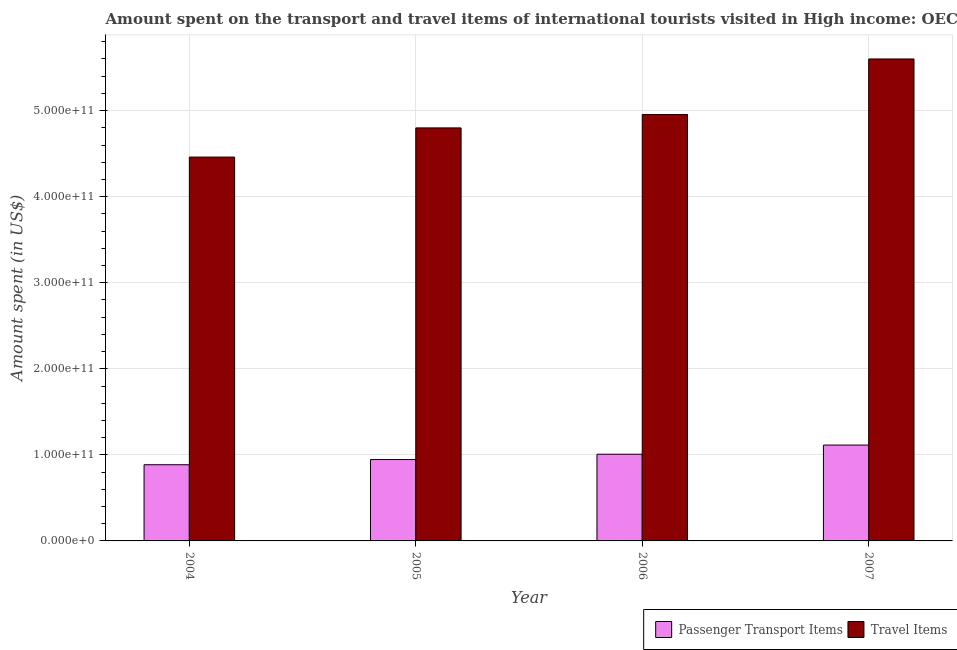How many different coloured bars are there?
Your response must be concise. 2. Are the number of bars per tick equal to the number of legend labels?
Give a very brief answer. Yes. What is the label of the 4th group of bars from the left?
Give a very brief answer. 2007. In how many cases, is the number of bars for a given year not equal to the number of legend labels?
Your answer should be compact. 0. What is the amount spent in travel items in 2005?
Your answer should be compact. 4.80e+11. Across all years, what is the maximum amount spent on passenger transport items?
Keep it short and to the point. 1.11e+11. Across all years, what is the minimum amount spent on passenger transport items?
Provide a succinct answer. 8.85e+1. In which year was the amount spent on passenger transport items maximum?
Give a very brief answer. 2007. In which year was the amount spent in travel items minimum?
Ensure brevity in your answer.  2004. What is the total amount spent in travel items in the graph?
Your answer should be compact. 1.98e+12. What is the difference between the amount spent on passenger transport items in 2004 and that in 2006?
Provide a succinct answer. -1.22e+1. What is the difference between the amount spent on passenger transport items in 2005 and the amount spent in travel items in 2004?
Offer a terse response. 6.03e+09. What is the average amount spent in travel items per year?
Your answer should be very brief. 4.95e+11. In the year 2006, what is the difference between the amount spent on passenger transport items and amount spent in travel items?
Offer a terse response. 0. In how many years, is the amount spent in travel items greater than 400000000000 US$?
Provide a short and direct response. 4. What is the ratio of the amount spent on passenger transport items in 2005 to that in 2007?
Offer a very short reply. 0.85. Is the amount spent in travel items in 2004 less than that in 2007?
Ensure brevity in your answer.  Yes. Is the difference between the amount spent on passenger transport items in 2004 and 2007 greater than the difference between the amount spent in travel items in 2004 and 2007?
Give a very brief answer. No. What is the difference between the highest and the second highest amount spent on passenger transport items?
Your answer should be very brief. 1.06e+1. What is the difference between the highest and the lowest amount spent on passenger transport items?
Make the answer very short. 2.28e+1. In how many years, is the amount spent on passenger transport items greater than the average amount spent on passenger transport items taken over all years?
Provide a succinct answer. 2. What does the 2nd bar from the left in 2004 represents?
Give a very brief answer. Travel Items. What does the 1st bar from the right in 2006 represents?
Your answer should be very brief. Travel Items. How many bars are there?
Provide a short and direct response. 8. What is the difference between two consecutive major ticks on the Y-axis?
Your answer should be very brief. 1.00e+11. Does the graph contain any zero values?
Give a very brief answer. No. Does the graph contain grids?
Your answer should be compact. Yes. What is the title of the graph?
Ensure brevity in your answer.  Amount spent on the transport and travel items of international tourists visited in High income: OECD. Does "Girls" appear as one of the legend labels in the graph?
Offer a terse response. No. What is the label or title of the X-axis?
Offer a terse response. Year. What is the label or title of the Y-axis?
Your answer should be very brief. Amount spent (in US$). What is the Amount spent (in US$) in Passenger Transport Items in 2004?
Your response must be concise. 8.85e+1. What is the Amount spent (in US$) of Travel Items in 2004?
Your answer should be compact. 4.46e+11. What is the Amount spent (in US$) of Passenger Transport Items in 2005?
Ensure brevity in your answer.  9.46e+1. What is the Amount spent (in US$) of Travel Items in 2005?
Provide a succinct answer. 4.80e+11. What is the Amount spent (in US$) in Passenger Transport Items in 2006?
Offer a very short reply. 1.01e+11. What is the Amount spent (in US$) of Travel Items in 2006?
Make the answer very short. 4.95e+11. What is the Amount spent (in US$) in Passenger Transport Items in 2007?
Your response must be concise. 1.11e+11. What is the Amount spent (in US$) in Travel Items in 2007?
Your response must be concise. 5.60e+11. Across all years, what is the maximum Amount spent (in US$) in Passenger Transport Items?
Your answer should be compact. 1.11e+11. Across all years, what is the maximum Amount spent (in US$) of Travel Items?
Provide a succinct answer. 5.60e+11. Across all years, what is the minimum Amount spent (in US$) in Passenger Transport Items?
Make the answer very short. 8.85e+1. Across all years, what is the minimum Amount spent (in US$) of Travel Items?
Your answer should be very brief. 4.46e+11. What is the total Amount spent (in US$) in Passenger Transport Items in the graph?
Make the answer very short. 3.95e+11. What is the total Amount spent (in US$) in Travel Items in the graph?
Offer a very short reply. 1.98e+12. What is the difference between the Amount spent (in US$) in Passenger Transport Items in 2004 and that in 2005?
Keep it short and to the point. -6.03e+09. What is the difference between the Amount spent (in US$) of Travel Items in 2004 and that in 2005?
Your answer should be very brief. -3.39e+1. What is the difference between the Amount spent (in US$) in Passenger Transport Items in 2004 and that in 2006?
Your answer should be very brief. -1.22e+1. What is the difference between the Amount spent (in US$) in Travel Items in 2004 and that in 2006?
Your answer should be very brief. -4.95e+1. What is the difference between the Amount spent (in US$) of Passenger Transport Items in 2004 and that in 2007?
Ensure brevity in your answer.  -2.28e+1. What is the difference between the Amount spent (in US$) of Travel Items in 2004 and that in 2007?
Ensure brevity in your answer.  -1.14e+11. What is the difference between the Amount spent (in US$) of Passenger Transport Items in 2005 and that in 2006?
Make the answer very short. -6.17e+09. What is the difference between the Amount spent (in US$) in Travel Items in 2005 and that in 2006?
Offer a terse response. -1.56e+1. What is the difference between the Amount spent (in US$) of Passenger Transport Items in 2005 and that in 2007?
Provide a succinct answer. -1.68e+1. What is the difference between the Amount spent (in US$) in Travel Items in 2005 and that in 2007?
Offer a terse response. -8.01e+1. What is the difference between the Amount spent (in US$) of Passenger Transport Items in 2006 and that in 2007?
Your answer should be compact. -1.06e+1. What is the difference between the Amount spent (in US$) of Travel Items in 2006 and that in 2007?
Ensure brevity in your answer.  -6.45e+1. What is the difference between the Amount spent (in US$) of Passenger Transport Items in 2004 and the Amount spent (in US$) of Travel Items in 2005?
Ensure brevity in your answer.  -3.91e+11. What is the difference between the Amount spent (in US$) in Passenger Transport Items in 2004 and the Amount spent (in US$) in Travel Items in 2006?
Make the answer very short. -4.07e+11. What is the difference between the Amount spent (in US$) in Passenger Transport Items in 2004 and the Amount spent (in US$) in Travel Items in 2007?
Your answer should be very brief. -4.71e+11. What is the difference between the Amount spent (in US$) in Passenger Transport Items in 2005 and the Amount spent (in US$) in Travel Items in 2006?
Make the answer very short. -4.01e+11. What is the difference between the Amount spent (in US$) in Passenger Transport Items in 2005 and the Amount spent (in US$) in Travel Items in 2007?
Give a very brief answer. -4.65e+11. What is the difference between the Amount spent (in US$) in Passenger Transport Items in 2006 and the Amount spent (in US$) in Travel Items in 2007?
Make the answer very short. -4.59e+11. What is the average Amount spent (in US$) in Passenger Transport Items per year?
Give a very brief answer. 9.88e+1. What is the average Amount spent (in US$) of Travel Items per year?
Give a very brief answer. 4.95e+11. In the year 2004, what is the difference between the Amount spent (in US$) in Passenger Transport Items and Amount spent (in US$) in Travel Items?
Make the answer very short. -3.57e+11. In the year 2005, what is the difference between the Amount spent (in US$) of Passenger Transport Items and Amount spent (in US$) of Travel Items?
Give a very brief answer. -3.85e+11. In the year 2006, what is the difference between the Amount spent (in US$) in Passenger Transport Items and Amount spent (in US$) in Travel Items?
Your answer should be very brief. -3.95e+11. In the year 2007, what is the difference between the Amount spent (in US$) in Passenger Transport Items and Amount spent (in US$) in Travel Items?
Your answer should be compact. -4.49e+11. What is the ratio of the Amount spent (in US$) of Passenger Transport Items in 2004 to that in 2005?
Offer a terse response. 0.94. What is the ratio of the Amount spent (in US$) in Travel Items in 2004 to that in 2005?
Your response must be concise. 0.93. What is the ratio of the Amount spent (in US$) in Passenger Transport Items in 2004 to that in 2006?
Offer a very short reply. 0.88. What is the ratio of the Amount spent (in US$) in Travel Items in 2004 to that in 2006?
Give a very brief answer. 0.9. What is the ratio of the Amount spent (in US$) of Passenger Transport Items in 2004 to that in 2007?
Ensure brevity in your answer.  0.8. What is the ratio of the Amount spent (in US$) in Travel Items in 2004 to that in 2007?
Make the answer very short. 0.8. What is the ratio of the Amount spent (in US$) of Passenger Transport Items in 2005 to that in 2006?
Offer a very short reply. 0.94. What is the ratio of the Amount spent (in US$) in Travel Items in 2005 to that in 2006?
Provide a short and direct response. 0.97. What is the ratio of the Amount spent (in US$) in Passenger Transport Items in 2005 to that in 2007?
Provide a succinct answer. 0.85. What is the ratio of the Amount spent (in US$) of Travel Items in 2005 to that in 2007?
Your response must be concise. 0.86. What is the ratio of the Amount spent (in US$) of Passenger Transport Items in 2006 to that in 2007?
Offer a terse response. 0.9. What is the ratio of the Amount spent (in US$) of Travel Items in 2006 to that in 2007?
Your response must be concise. 0.88. What is the difference between the highest and the second highest Amount spent (in US$) of Passenger Transport Items?
Offer a very short reply. 1.06e+1. What is the difference between the highest and the second highest Amount spent (in US$) in Travel Items?
Your answer should be very brief. 6.45e+1. What is the difference between the highest and the lowest Amount spent (in US$) in Passenger Transport Items?
Your response must be concise. 2.28e+1. What is the difference between the highest and the lowest Amount spent (in US$) of Travel Items?
Provide a succinct answer. 1.14e+11. 